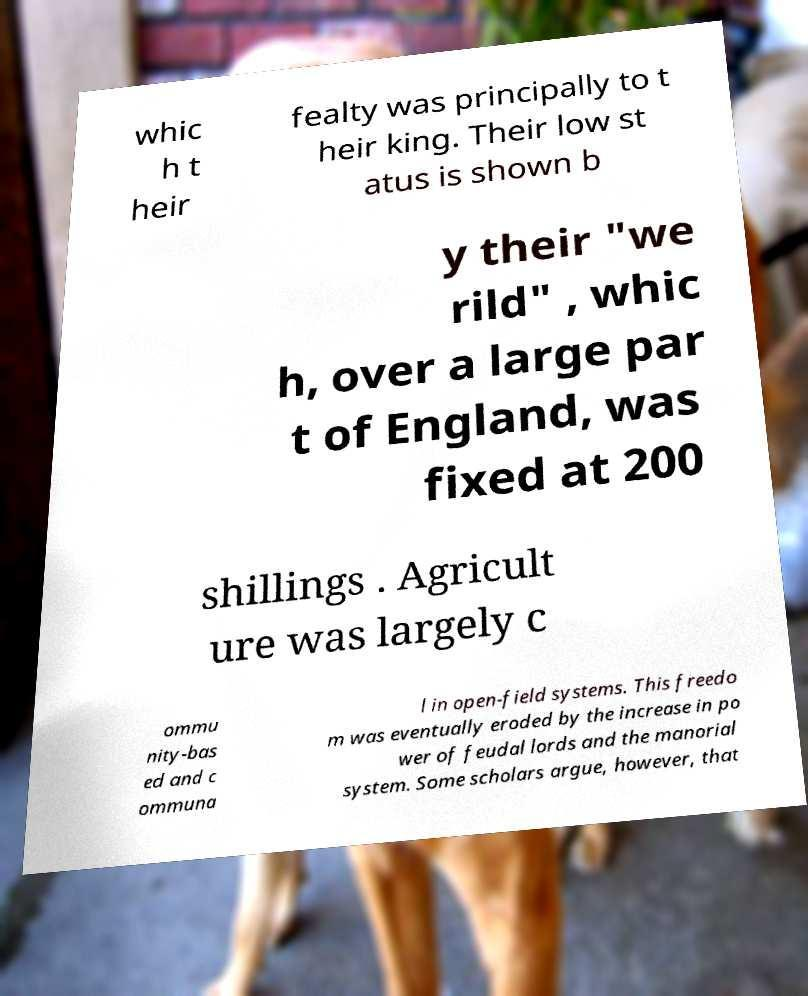What messages or text are displayed in this image? I need them in a readable, typed format. whic h t heir fealty was principally to t heir king. Their low st atus is shown b y their "we rild" , whic h, over a large par t of England, was fixed at 200 shillings . Agricult ure was largely c ommu nity-bas ed and c ommuna l in open-field systems. This freedo m was eventually eroded by the increase in po wer of feudal lords and the manorial system. Some scholars argue, however, that 